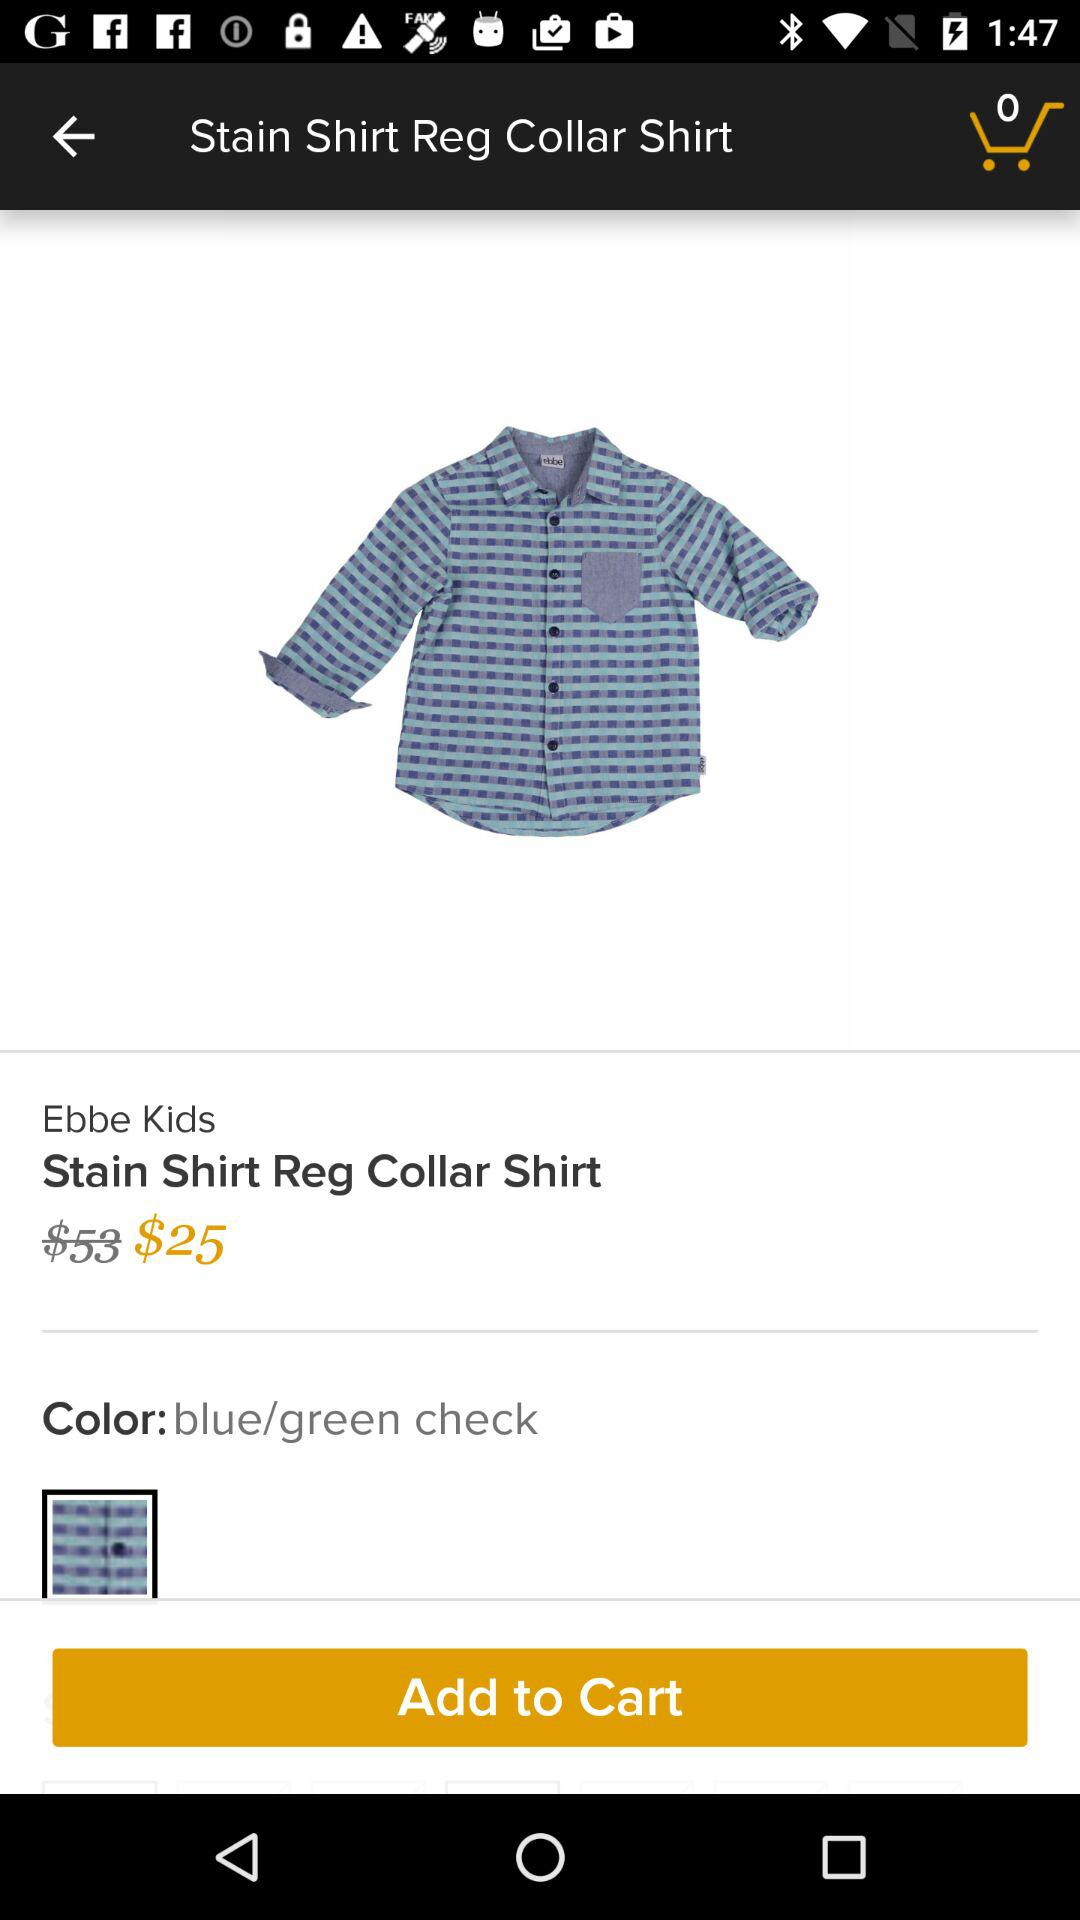What is the price of the shirt after the discount? The price of the shirt after the discount is $25. 